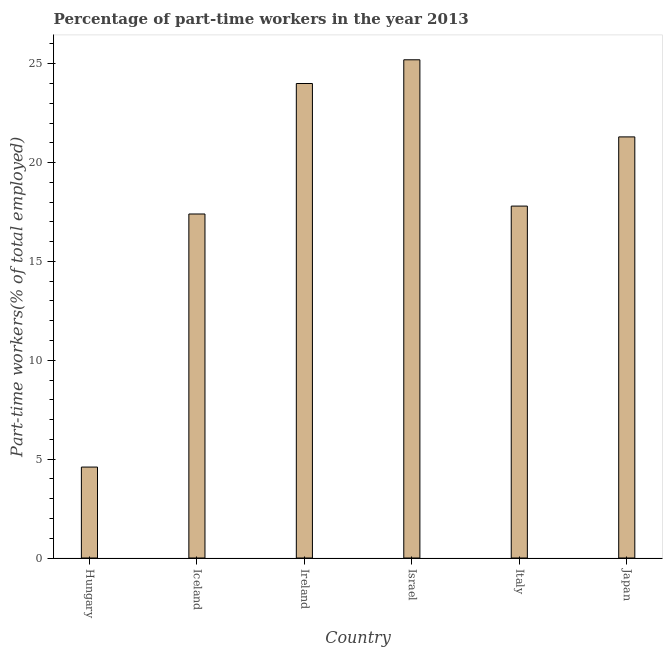Does the graph contain any zero values?
Offer a very short reply. No. Does the graph contain grids?
Offer a terse response. No. What is the title of the graph?
Provide a short and direct response. Percentage of part-time workers in the year 2013. What is the label or title of the Y-axis?
Give a very brief answer. Part-time workers(% of total employed). What is the percentage of part-time workers in Hungary?
Make the answer very short. 4.6. Across all countries, what is the maximum percentage of part-time workers?
Make the answer very short. 25.2. Across all countries, what is the minimum percentage of part-time workers?
Keep it short and to the point. 4.6. In which country was the percentage of part-time workers maximum?
Provide a succinct answer. Israel. In which country was the percentage of part-time workers minimum?
Ensure brevity in your answer.  Hungary. What is the sum of the percentage of part-time workers?
Your answer should be very brief. 110.3. What is the difference between the percentage of part-time workers in Hungary and Ireland?
Provide a succinct answer. -19.4. What is the average percentage of part-time workers per country?
Your answer should be very brief. 18.38. What is the median percentage of part-time workers?
Offer a terse response. 19.55. In how many countries, is the percentage of part-time workers greater than 4 %?
Offer a terse response. 6. What is the ratio of the percentage of part-time workers in Hungary to that in Japan?
Ensure brevity in your answer.  0.22. Is the difference between the percentage of part-time workers in Italy and Japan greater than the difference between any two countries?
Your response must be concise. No. What is the difference between the highest and the second highest percentage of part-time workers?
Ensure brevity in your answer.  1.2. What is the difference between the highest and the lowest percentage of part-time workers?
Offer a very short reply. 20.6. How many bars are there?
Keep it short and to the point. 6. Are the values on the major ticks of Y-axis written in scientific E-notation?
Provide a short and direct response. No. What is the Part-time workers(% of total employed) in Hungary?
Give a very brief answer. 4.6. What is the Part-time workers(% of total employed) in Iceland?
Provide a short and direct response. 17.4. What is the Part-time workers(% of total employed) of Israel?
Your answer should be compact. 25.2. What is the Part-time workers(% of total employed) in Italy?
Your answer should be very brief. 17.8. What is the Part-time workers(% of total employed) in Japan?
Your response must be concise. 21.3. What is the difference between the Part-time workers(% of total employed) in Hungary and Iceland?
Keep it short and to the point. -12.8. What is the difference between the Part-time workers(% of total employed) in Hungary and Ireland?
Provide a succinct answer. -19.4. What is the difference between the Part-time workers(% of total employed) in Hungary and Israel?
Make the answer very short. -20.6. What is the difference between the Part-time workers(% of total employed) in Hungary and Japan?
Give a very brief answer. -16.7. What is the difference between the Part-time workers(% of total employed) in Iceland and Israel?
Offer a very short reply. -7.8. What is the difference between the Part-time workers(% of total employed) in Ireland and Japan?
Make the answer very short. 2.7. What is the difference between the Part-time workers(% of total employed) in Israel and Italy?
Offer a very short reply. 7.4. What is the difference between the Part-time workers(% of total employed) in Italy and Japan?
Offer a terse response. -3.5. What is the ratio of the Part-time workers(% of total employed) in Hungary to that in Iceland?
Provide a short and direct response. 0.26. What is the ratio of the Part-time workers(% of total employed) in Hungary to that in Ireland?
Keep it short and to the point. 0.19. What is the ratio of the Part-time workers(% of total employed) in Hungary to that in Israel?
Offer a terse response. 0.18. What is the ratio of the Part-time workers(% of total employed) in Hungary to that in Italy?
Your response must be concise. 0.26. What is the ratio of the Part-time workers(% of total employed) in Hungary to that in Japan?
Offer a very short reply. 0.22. What is the ratio of the Part-time workers(% of total employed) in Iceland to that in Ireland?
Keep it short and to the point. 0.72. What is the ratio of the Part-time workers(% of total employed) in Iceland to that in Israel?
Make the answer very short. 0.69. What is the ratio of the Part-time workers(% of total employed) in Iceland to that in Italy?
Provide a short and direct response. 0.98. What is the ratio of the Part-time workers(% of total employed) in Iceland to that in Japan?
Ensure brevity in your answer.  0.82. What is the ratio of the Part-time workers(% of total employed) in Ireland to that in Italy?
Offer a terse response. 1.35. What is the ratio of the Part-time workers(% of total employed) in Ireland to that in Japan?
Ensure brevity in your answer.  1.13. What is the ratio of the Part-time workers(% of total employed) in Israel to that in Italy?
Offer a very short reply. 1.42. What is the ratio of the Part-time workers(% of total employed) in Israel to that in Japan?
Offer a very short reply. 1.18. What is the ratio of the Part-time workers(% of total employed) in Italy to that in Japan?
Your answer should be very brief. 0.84. 